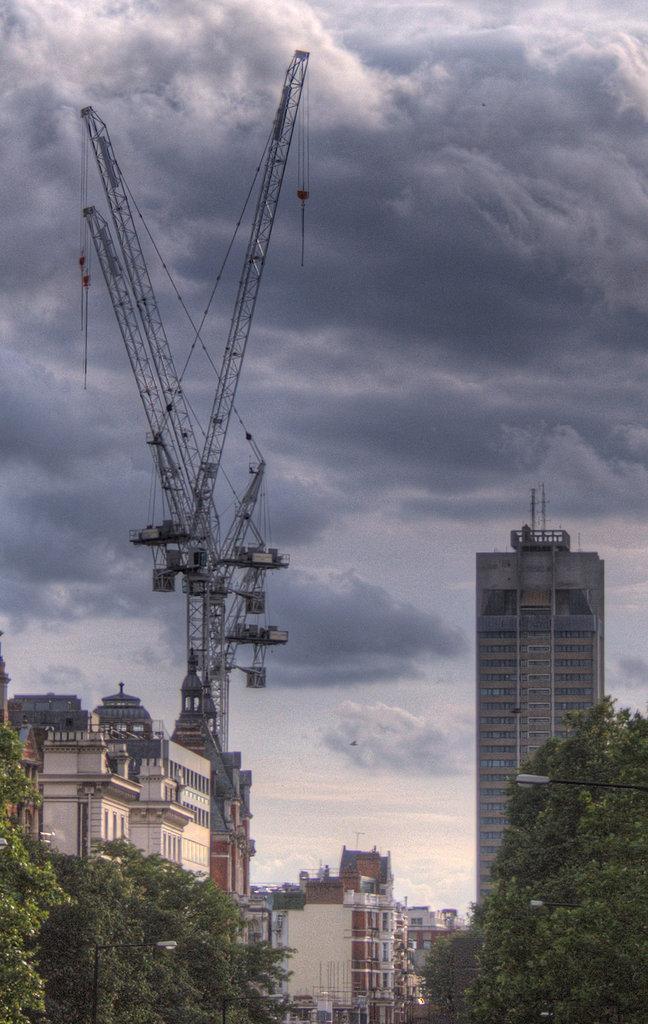Can you describe this image briefly? In the foreground of the picture there are trees. In the center of the picture there are buildings and machinery. In the background it is sky. 